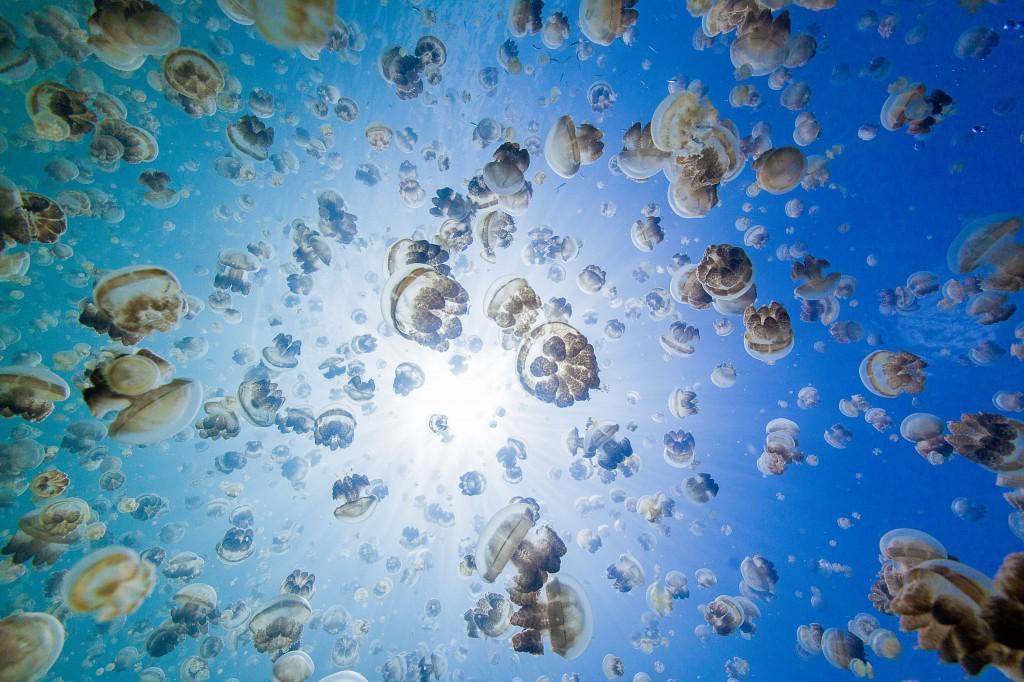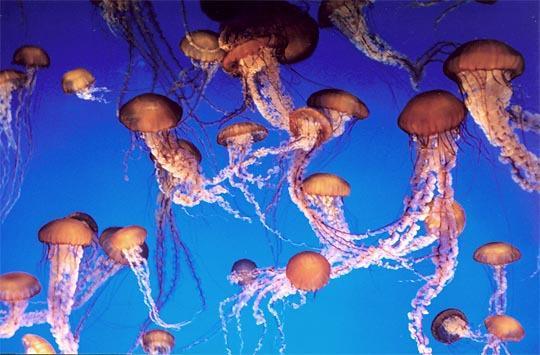The first image is the image on the left, the second image is the image on the right. For the images displayed, is the sentence "There are at least 7 jellyfish swimming down." factually correct? Answer yes or no. No. The first image is the image on the left, the second image is the image on the right. For the images displayed, is the sentence "all of the jellyfish are swimming with the body facing downward" factually correct? Answer yes or no. No. 